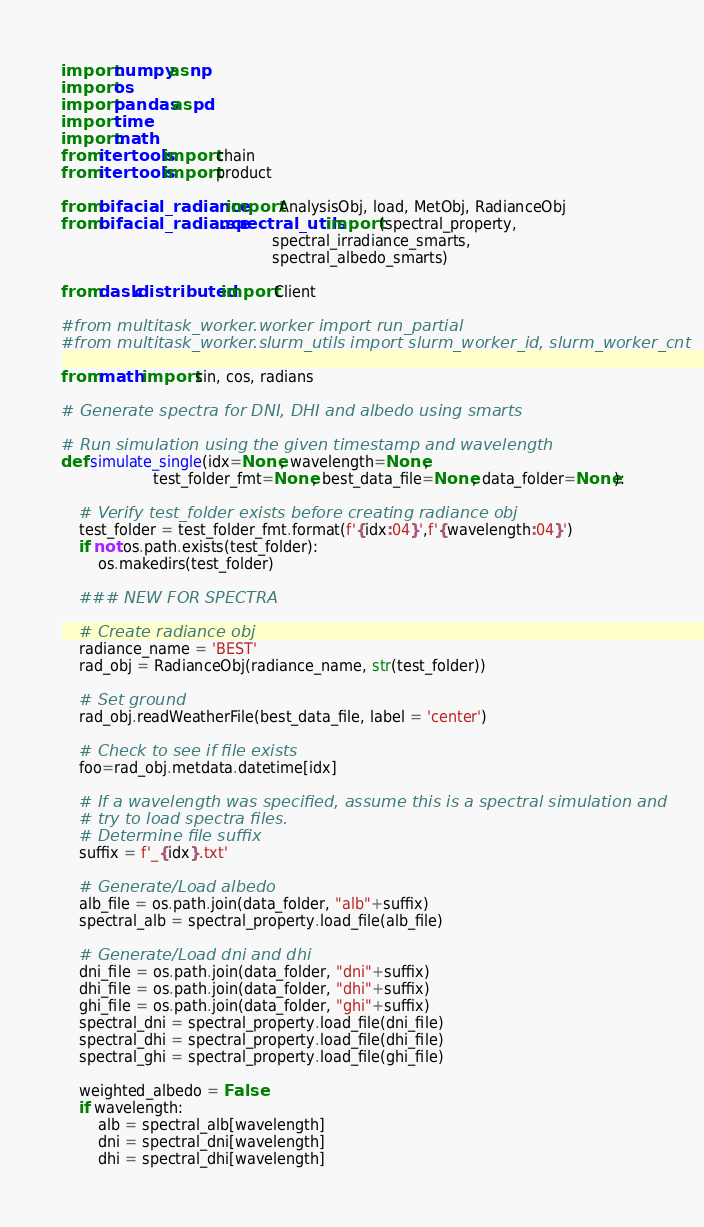<code> <loc_0><loc_0><loc_500><loc_500><_Python_>import numpy as np
import os
import pandas as pd
import time
import math
from itertools import chain
from itertools import product

from bifacial_radiance import AnalysisObj, load, MetObj, RadianceObj
from bifacial_radiance.spectral_utils import (spectral_property,
                                              spectral_irradiance_smarts,
                                              spectral_albedo_smarts)

from dask.distributed import Client

#from multitask_worker.worker import run_partial
#from multitask_worker.slurm_utils import slurm_worker_id, slurm_worker_cnt

from math import sin, cos, radians

# Generate spectra for DNI, DHI and albedo using smarts

# Run simulation using the given timestamp and wavelength
def simulate_single(idx=None, wavelength=None, 
                    test_folder_fmt=None, best_data_file=None, data_folder=None):    
    
    # Verify test_folder exists before creating radiance obj
    test_folder = test_folder_fmt.format(f'{idx:04}',f'{wavelength:04}')
    if not os.path.exists(test_folder):
        os.makedirs(test_folder)

    ### NEW FOR SPECTRA 
    
    # Create radiance obj
    radiance_name = 'BEST'
    rad_obj = RadianceObj(radiance_name, str(test_folder))
    
    # Set ground
    rad_obj.readWeatherFile(best_data_file, label = 'center')
    
    # Check to see if file exists
    foo=rad_obj.metdata.datetime[idx]

    # If a wavelength was specified, assume this is a spectral simulation and
    # try to load spectra files.
    # Determine file suffix
    suffix = f'_{idx}.txt'
    
    # Generate/Load albedo
    alb_file = os.path.join(data_folder, "alb"+suffix)
    spectral_alb = spectral_property.load_file(alb_file)
                
    # Generate/Load dni and dhi
    dni_file = os.path.join(data_folder, "dni"+suffix)
    dhi_file = os.path.join(data_folder, "dhi"+suffix)
    ghi_file = os.path.join(data_folder, "ghi"+suffix)
    spectral_dni = spectral_property.load_file(dni_file)
    spectral_dhi = spectral_property.load_file(dhi_file)
    spectral_ghi = spectral_property.load_file(ghi_file)
            
    weighted_albedo = False
    if wavelength:
        alb = spectral_alb[wavelength]
        dni = spectral_dni[wavelength]
        dhi = spectral_dhi[wavelength]</code> 